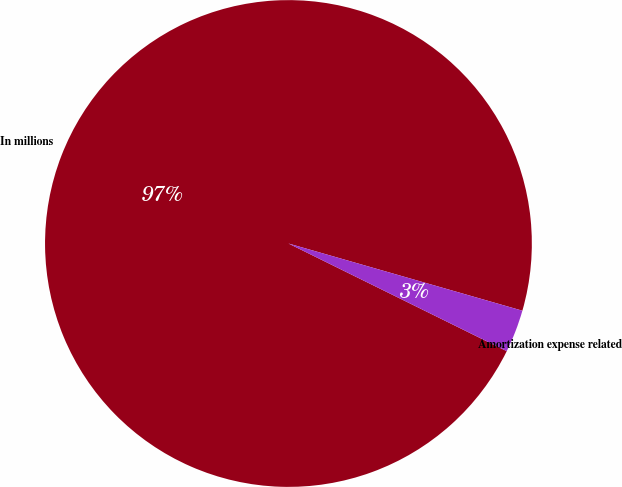Convert chart to OTSL. <chart><loc_0><loc_0><loc_500><loc_500><pie_chart><fcel>In millions<fcel>Amortization expense related<nl><fcel>97.16%<fcel>2.84%<nl></chart> 